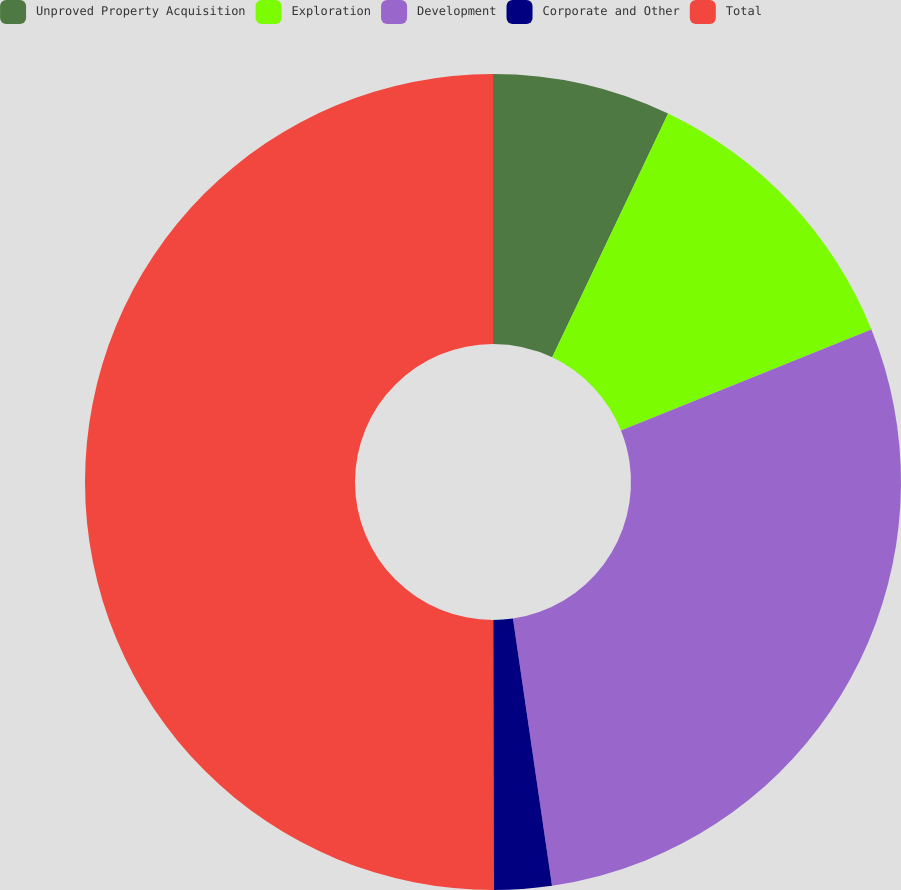Convert chart. <chart><loc_0><loc_0><loc_500><loc_500><pie_chart><fcel>Unproved Property Acquisition<fcel>Exploration<fcel>Development<fcel>Corporate and Other<fcel>Total<nl><fcel>7.06%<fcel>11.84%<fcel>28.79%<fcel>2.29%<fcel>50.02%<nl></chart> 